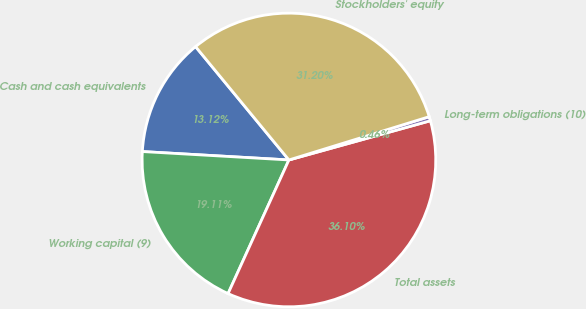Convert chart. <chart><loc_0><loc_0><loc_500><loc_500><pie_chart><fcel>Cash and cash equivalents<fcel>Working capital (9)<fcel>Total assets<fcel>Long-term obligations (10)<fcel>Stockholders' equity<nl><fcel>13.12%<fcel>19.11%<fcel>36.1%<fcel>0.46%<fcel>31.2%<nl></chart> 